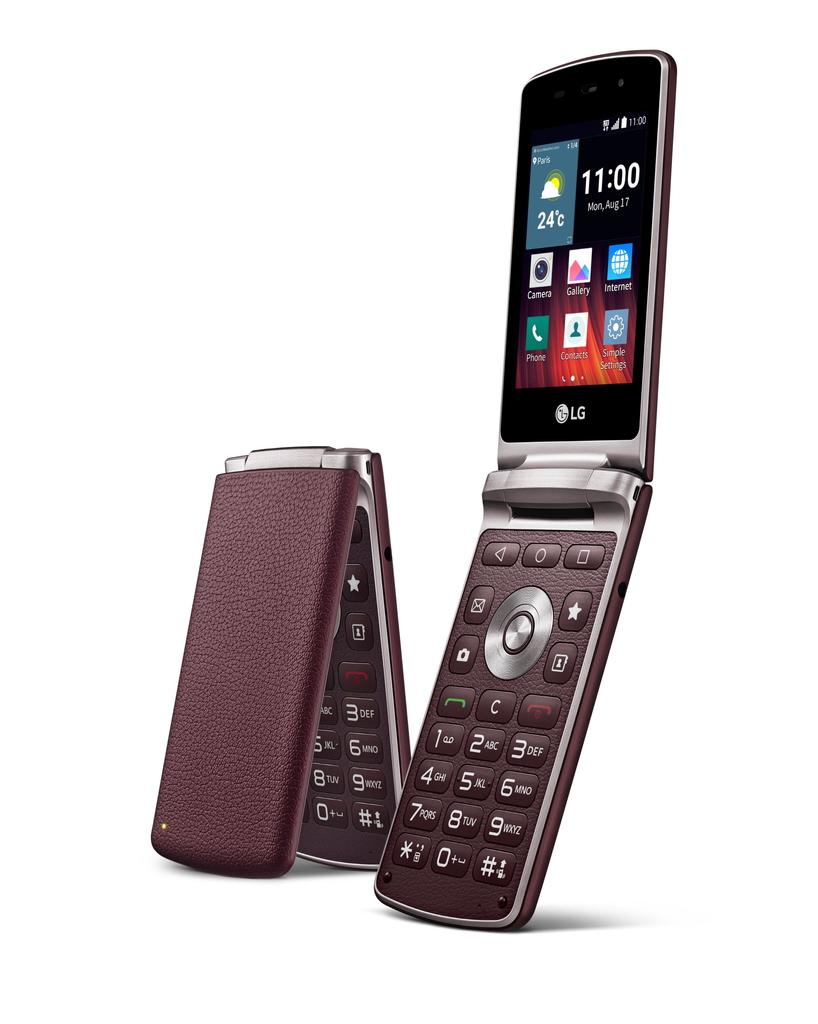How many cellular phones are visible in the image? There are two cellular phones in the image. Where are the cellular phones located in the image? The cellular phones are placed on a surface. What type of bird is hiding in the drawer in the image? There is no bird or drawer present in the image; it only features two cellular phones placed on a surface. 